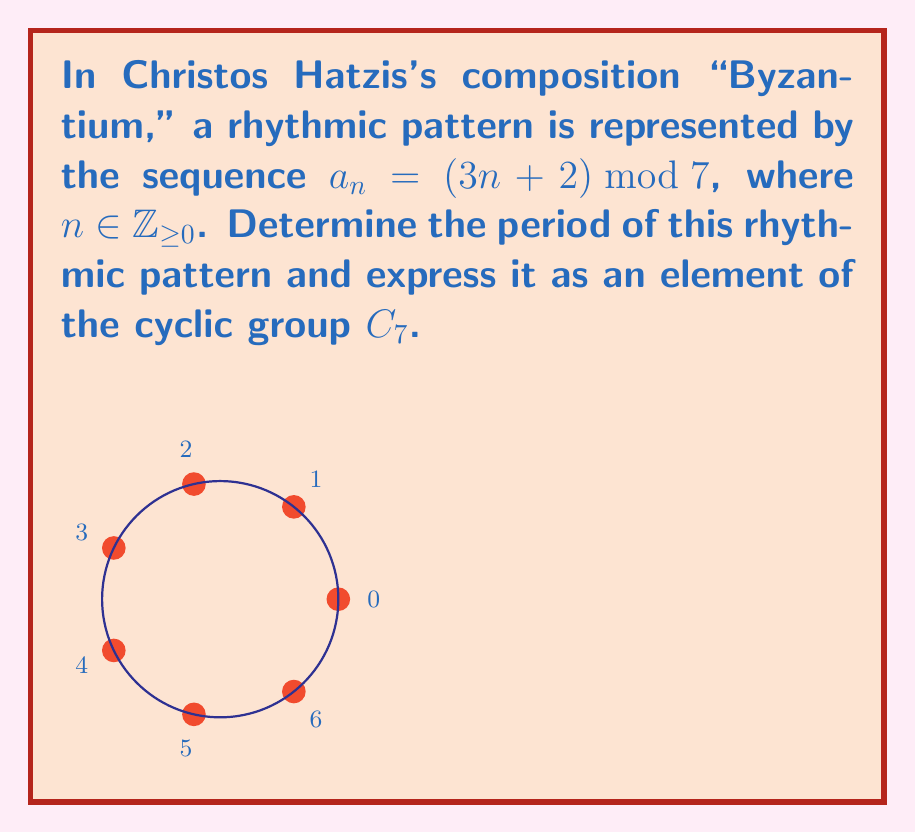What is the answer to this math problem? Let's approach this step-by-step:

1) First, we need to understand what the sequence represents. For each $n$, $a_n$ gives us an element of $\mathbb{Z}_7$ (integers modulo 7).

2) To find the period, we need to determine after how many steps the sequence repeats. Let's calculate the first few terms:

   $a_0 = (3(0) + 2) \bmod 7 = 2$
   $a_1 = (3(1) + 2) \bmod 7 = 5$
   $a_2 = (3(2) + 2) \bmod 7 = 1$
   $a_3 = (3(3) + 2) \bmod 7 = 4$
   $a_4 = (3(4) + 2) \bmod 7 = 0$
   $a_5 = (3(5) + 2) \bmod 7 = 3$
   $a_6 = (3(6) + 2) \bmod 7 = 6$
   $a_7 = (3(7) + 2) \bmod 7 = 2$

3) We see that $a_7 = a_0$, so the sequence repeats after 7 steps.

4) This means the period of the rhythmic pattern is 7.

5) In the cyclic group $C_7$, the element that generates the entire group when applied repeatedly is 1. This element is called the generator of the group.

6) Our sequence can be generated by repeatedly adding 3 (modulo 7) to the previous term. In group theory terms, this is equivalent to applying the group operation 3 times in each step.

7) Therefore, in $C_7$, our rhythmic pattern can be represented by the element 3.
Answer: Period: 7; Group element: 3 in $C_7$ 